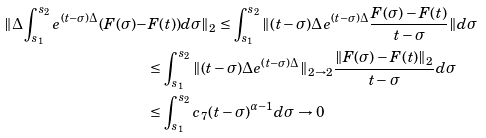<formula> <loc_0><loc_0><loc_500><loc_500>\| \Delta \int _ { s _ { 1 } } ^ { s _ { 2 } } e ^ { ( t - \sigma ) \Delta } ( F ( \sigma ) - & F ( t ) ) d \sigma \| _ { 2 } \leq \int _ { s _ { 1 } } ^ { s _ { 2 } } \| ( t - \sigma ) \Delta e ^ { ( t - \sigma ) \Delta } \frac { F ( \sigma ) - F ( t ) } { t - \sigma } \| d \sigma \\ & \leq \int _ { s _ { 1 } } ^ { s _ { 2 } } \| ( t - \sigma ) \Delta e ^ { ( t - \sigma ) \Delta } \| _ { 2 \rightarrow 2 } \frac { \| F ( \sigma ) - F ( t ) \| _ { 2 } } { t - \sigma } d \sigma \\ & \leq \int _ { s _ { 1 } } ^ { s _ { 2 } } c _ { 7 } ( t - \sigma ) ^ { \alpha - 1 } d \sigma \rightarrow 0</formula> 